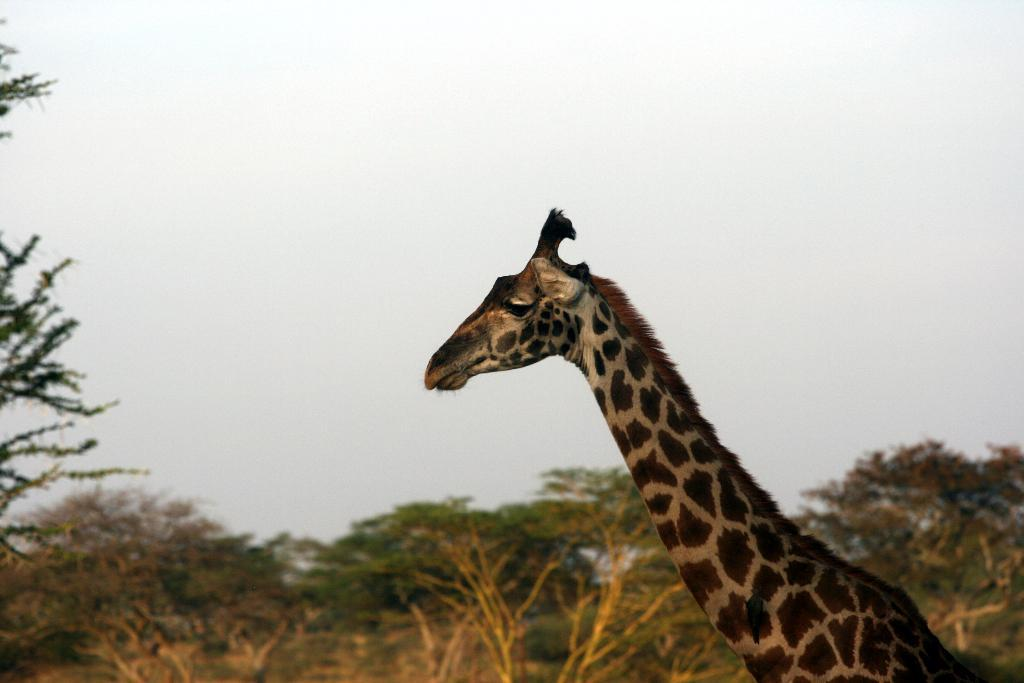What animal is the main subject of the picture? There is a giraffe in the picture. What can be seen in the background of the picture? There are trees and the sky visible in the background of the picture. What arithmetic problem is the giraffe trying to solve in the picture? There is no arithmetic problem present in the image; it features a giraffe in a natural setting. 